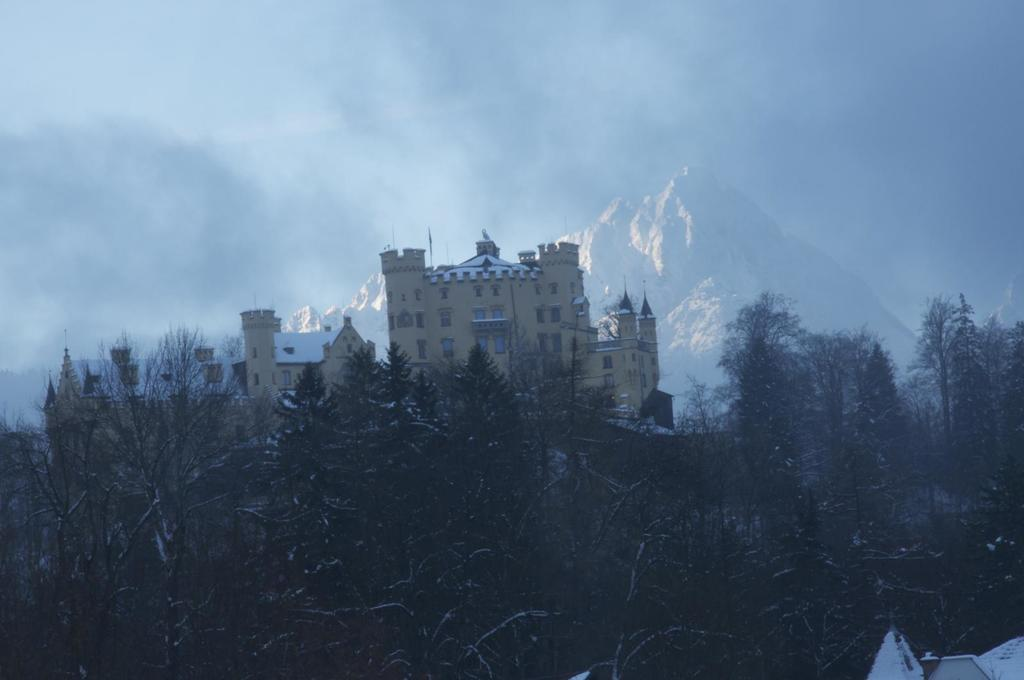What type of natural elements are at the bottom of the image? There are trees at the bottom of the image. What structure is located in the middle of the image? There is a building in the middle of the image. What can be seen in the background of the image? There are hills or mountains in the background of the image. Can you describe the building in the right bottom of the image? There is a white-colored building in the right bottom of the image. What type of engine can be seen powering the chickens in the image? There are no chickens or engines present in the image. How does the image start to convey its message? The image does not have a start or a message to convey; it is a static representation of the scene described in the facts. 